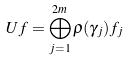Convert formula to latex. <formula><loc_0><loc_0><loc_500><loc_500>U f = \bigoplus _ { j = 1 } ^ { 2 m } \varrho ( \gamma _ { j } ) f _ { j }</formula> 